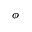Convert formula to latex. <formula><loc_0><loc_0><loc_500><loc_500>\phi</formula> 